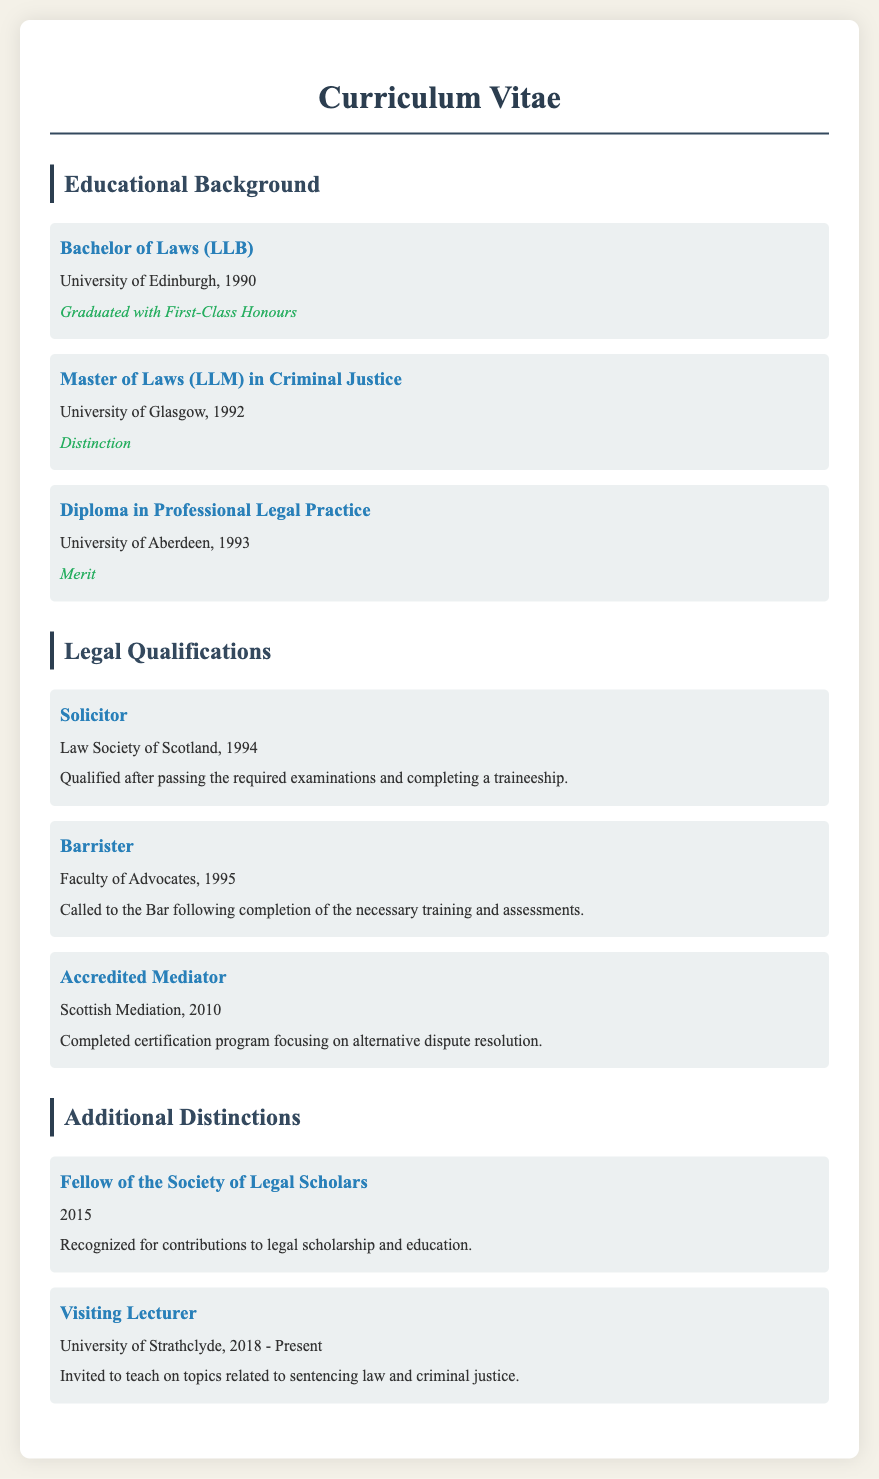What degree was obtained from the University of Edinburgh? The document states that a Bachelor of Laws (LLB) was obtained from the University of Edinburgh.
Answer: Bachelor of Laws (LLB) What year was the Diploma in Professional Legal Practice awarded? The document indicates that the Diploma in Professional Legal Practice was awarded in 1993.
Answer: 1993 Which institution awarded the Master of Laws (LLM) in Criminal Justice? The document specifies that the University of Glasgow awarded the Master of Laws (LLM) in Criminal Justice.
Answer: University of Glasgow What type of legal qualification was obtained in 1995? According to the document, the qualification obtained in 1995 was Barrister.
Answer: Barrister What honor was received for the LLM degree? The document states that the honor received for the LLM degree was Distinction.
Answer: Distinction How many years after obtaining the LLB was the solicitor qualification achieved? The document shows that the solicitor qualification was achieved four years after obtaining the LLB in 1990, which was in 1994.
Answer: Four years What is the latest educational role listed in the document? The document notes that the latest educational role is Visiting Lecturer at the University of Strathclyde.
Answer: Visiting Lecturer What does being an Accredited Mediator signify? The document clarifies that being an Accredited Mediator signifies completing a certification program focused on alternative dispute resolution.
Answer: Certification program Which distinction recognizes contributions to legal scholarship and education? The document mentions being a Fellow of the Society of Legal Scholars recognizes contributions to legal scholarship and education.
Answer: Fellow of the Society of Legal Scholars 